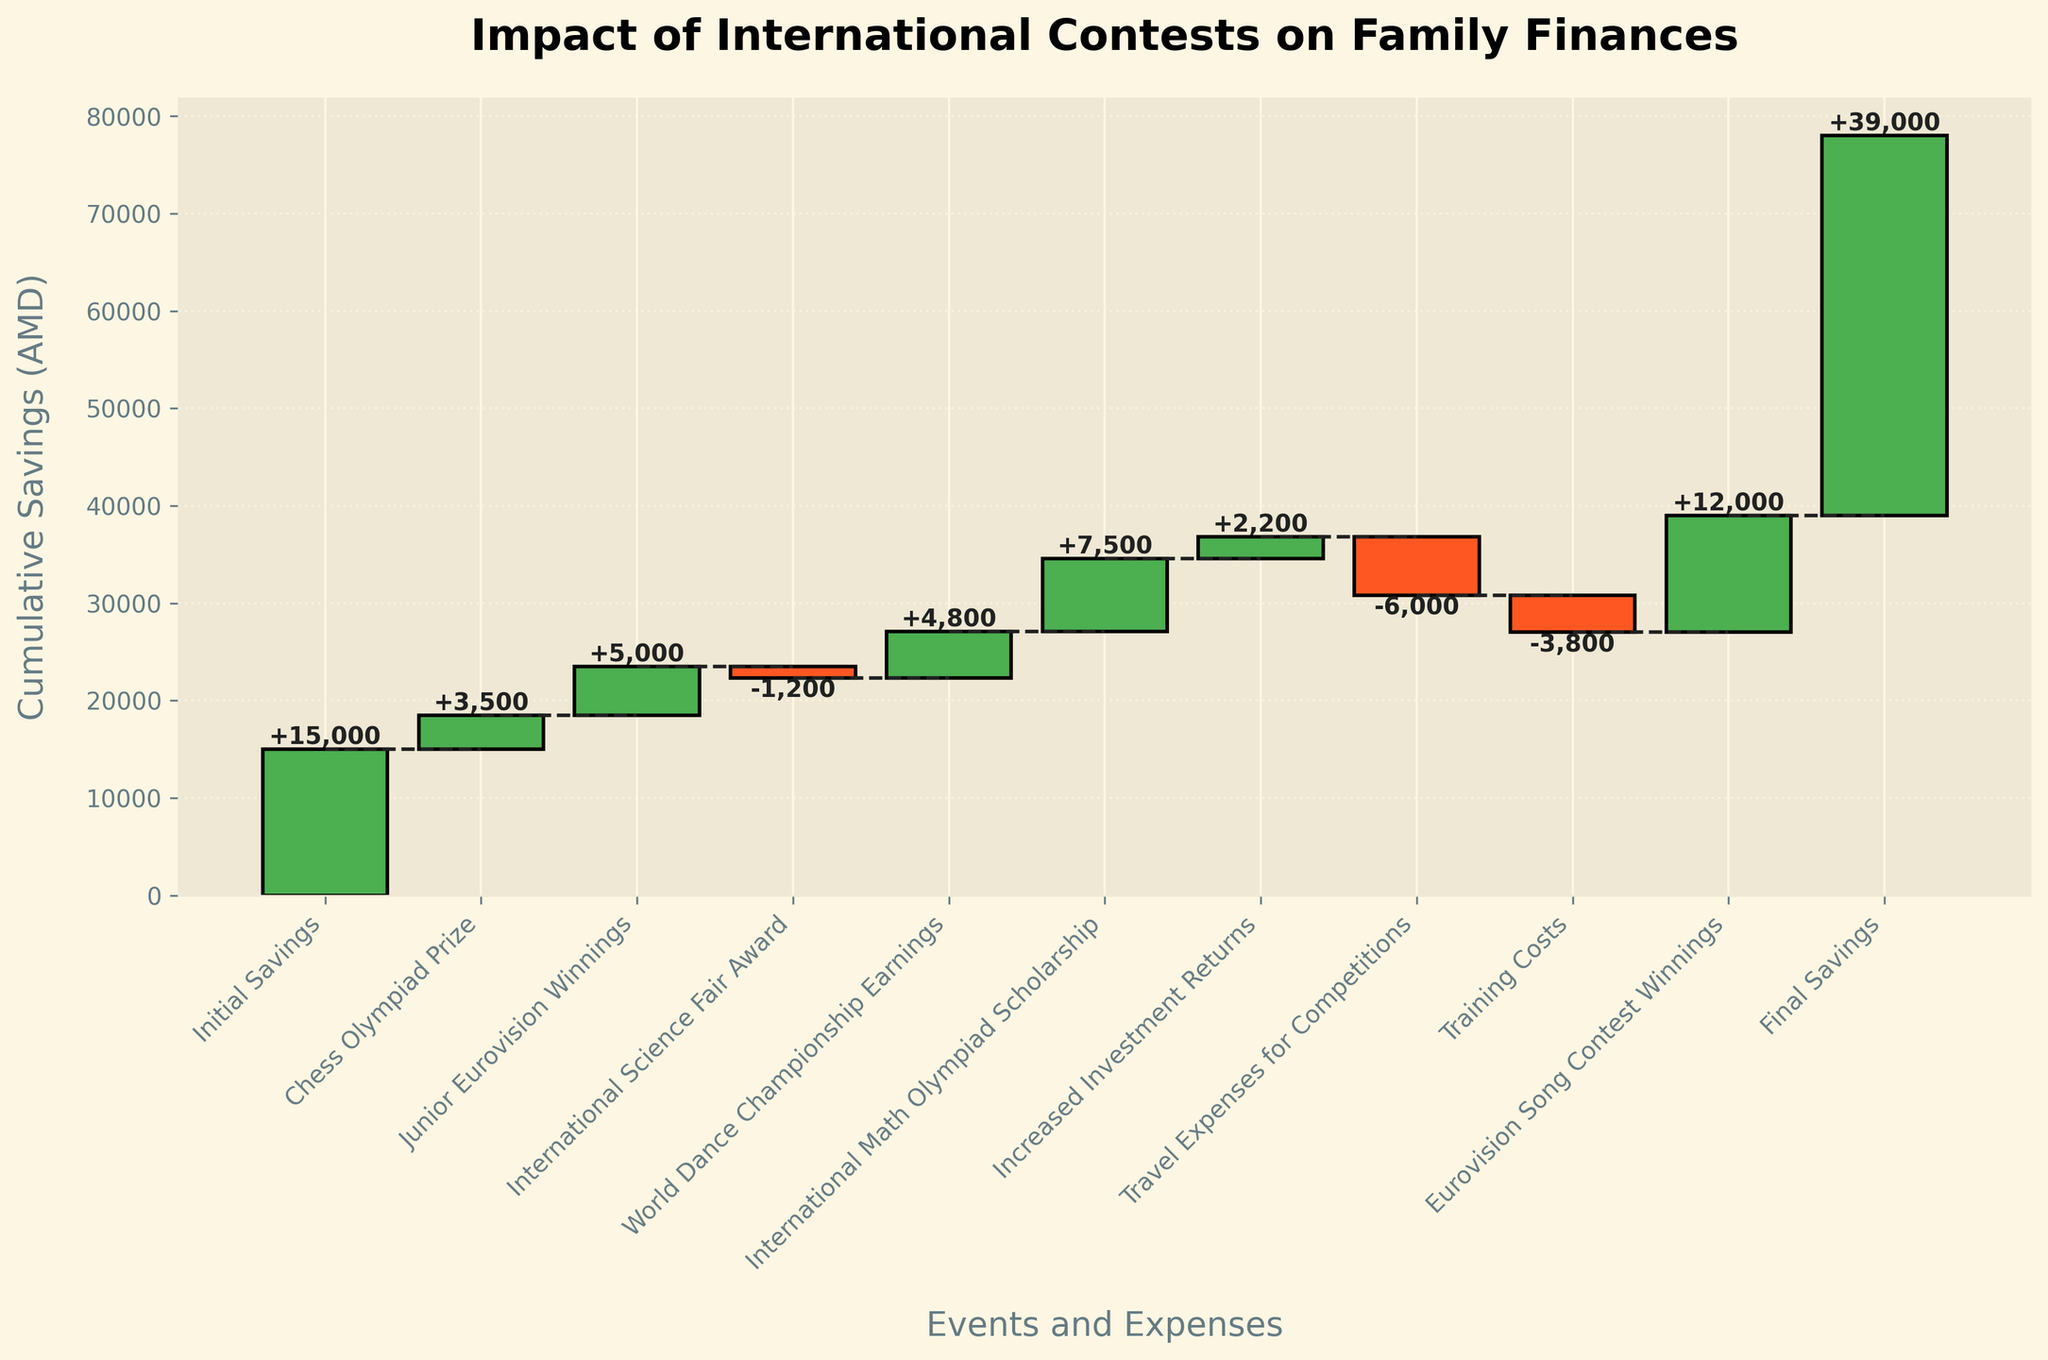What is the title of the chart? The title of the chart is generally placed at the top of the figure. Here, we can see the title "Impact of International Contests on Family Finances" at the top.
Answer: Impact of International Contests on Family Finances How many events and expenses are listed in the chart? The chart lists multiple events and expenses along the x-axis. Counting all the bars from left to right gives a total of 10 events and expenses.
Answer: 10 Which event added the most to the family's savings? To find the event that added the most to the family's savings, we look for the bar with the largest positive value. The "Eurovision Song Contest Winnings" shows the highest positive value, adding 12,000 AMD to the family's savings.
Answer: Eurovision Song Contest Winnings What was the net impact after the International Science Fair Award? To find the net impact after the "International Science Fair Award", look at the cumulative value at that point. After subtracting 1,200 AMD, the cumulative savings is visible from the plot.
Answer: 17,300 AMD What are the total positive contributions to the savings? Total positive contributions are found by summing up all the positive values. Chess Olympiad Prize (3,500) + Junior Eurovision Winnings (5,000) + World Dance Championship Earnings (4,800) + International Math Olympiad Scholarship (7,500) + Increased Investment Returns (2,200) + Eurovision Song Contest Winnings (12,000) = 35,000 AMD.
Answer: 35,000 AMD Which category had the highest negative impact on the savings? To find the highest negative impact, look for the bar with the largest negative value. The “Travel Expenses for Competitions” at -6,000 AMD shows the highest negative impact.
Answer: Travel Expenses for Competitions How much did the final savings increase from the initial savings? To find the increase, subtract the initial savings from the final savings. Final Savings (39,000) - Initial Savings (15,000) = 24,000 AMD.
Answer: 24,000 AMD What was the cumulative savings just before the Eurovision Song Contest Winnings? To find this, look for the cumulative value before the Eurovision Song Contest Winnings. This sum is visible before adding 12,000 AMD.
Answer: 27,000 AMD (16,000 + 4,800 + 7,500 - 6,000 - 3,800 + 2,200 = 27,000) What is the average net impact of all categories? To find the average net impact, sum all the values and divide by the number of categories. Total sum of values is 39,000 - 15,000 (Initial Savings subtracted from Final Savings) = 24,000. Then, divide by the 10 events and expenses: 24,000 / 10 = 2,400 AMD.
Answer: 2,400 AMD 